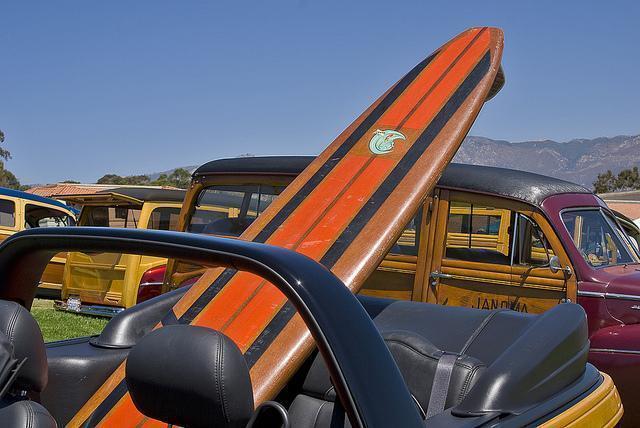Who played the character on the Brady Bunch whose name can be spelled with the first three letters shown on the vehicle?
Indicate the correct choice and explain in the format: 'Answer: answer
Rationale: rationale.'
Options: Eve plumb, christopher knight, mike lookinland, susan olsen. Answer: eve plumb.
Rationale: The first three letters on the vehicle match the character. 